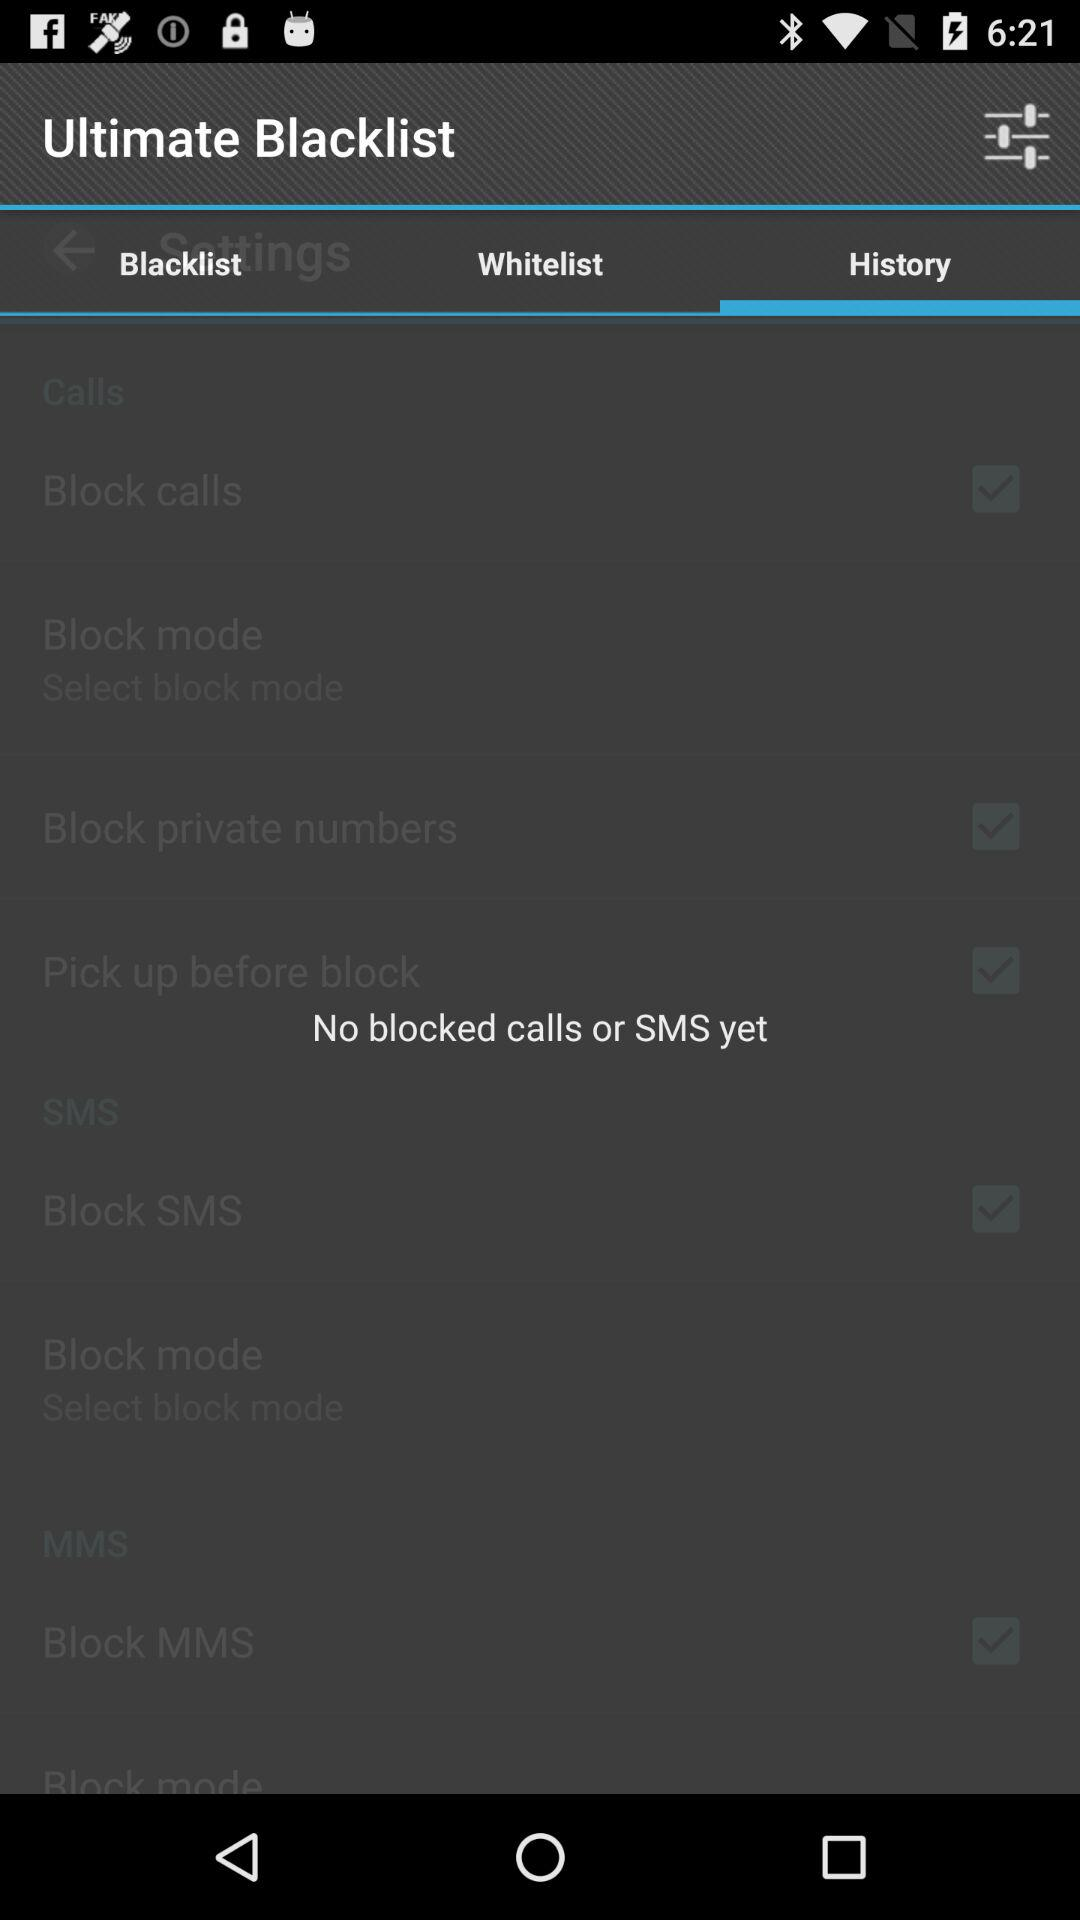Which tab is currently selected? The selected tab is "History". 